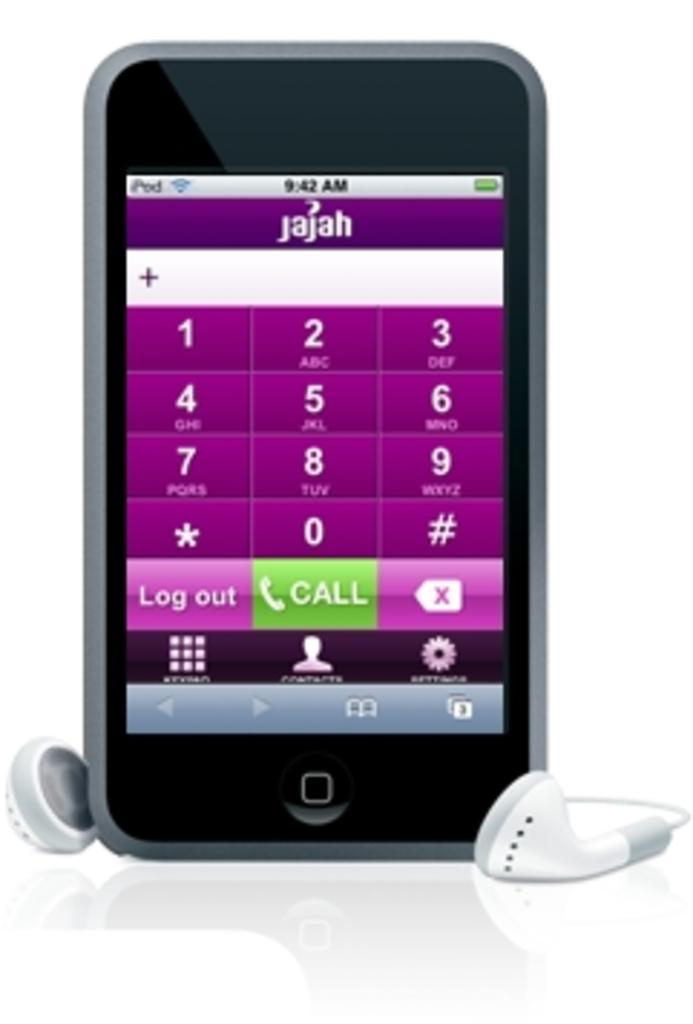How would you summarize this image in a sentence or two? In this image we can see a mobile phone with display of numbers, text and other things and we can see earphones on the surface. 